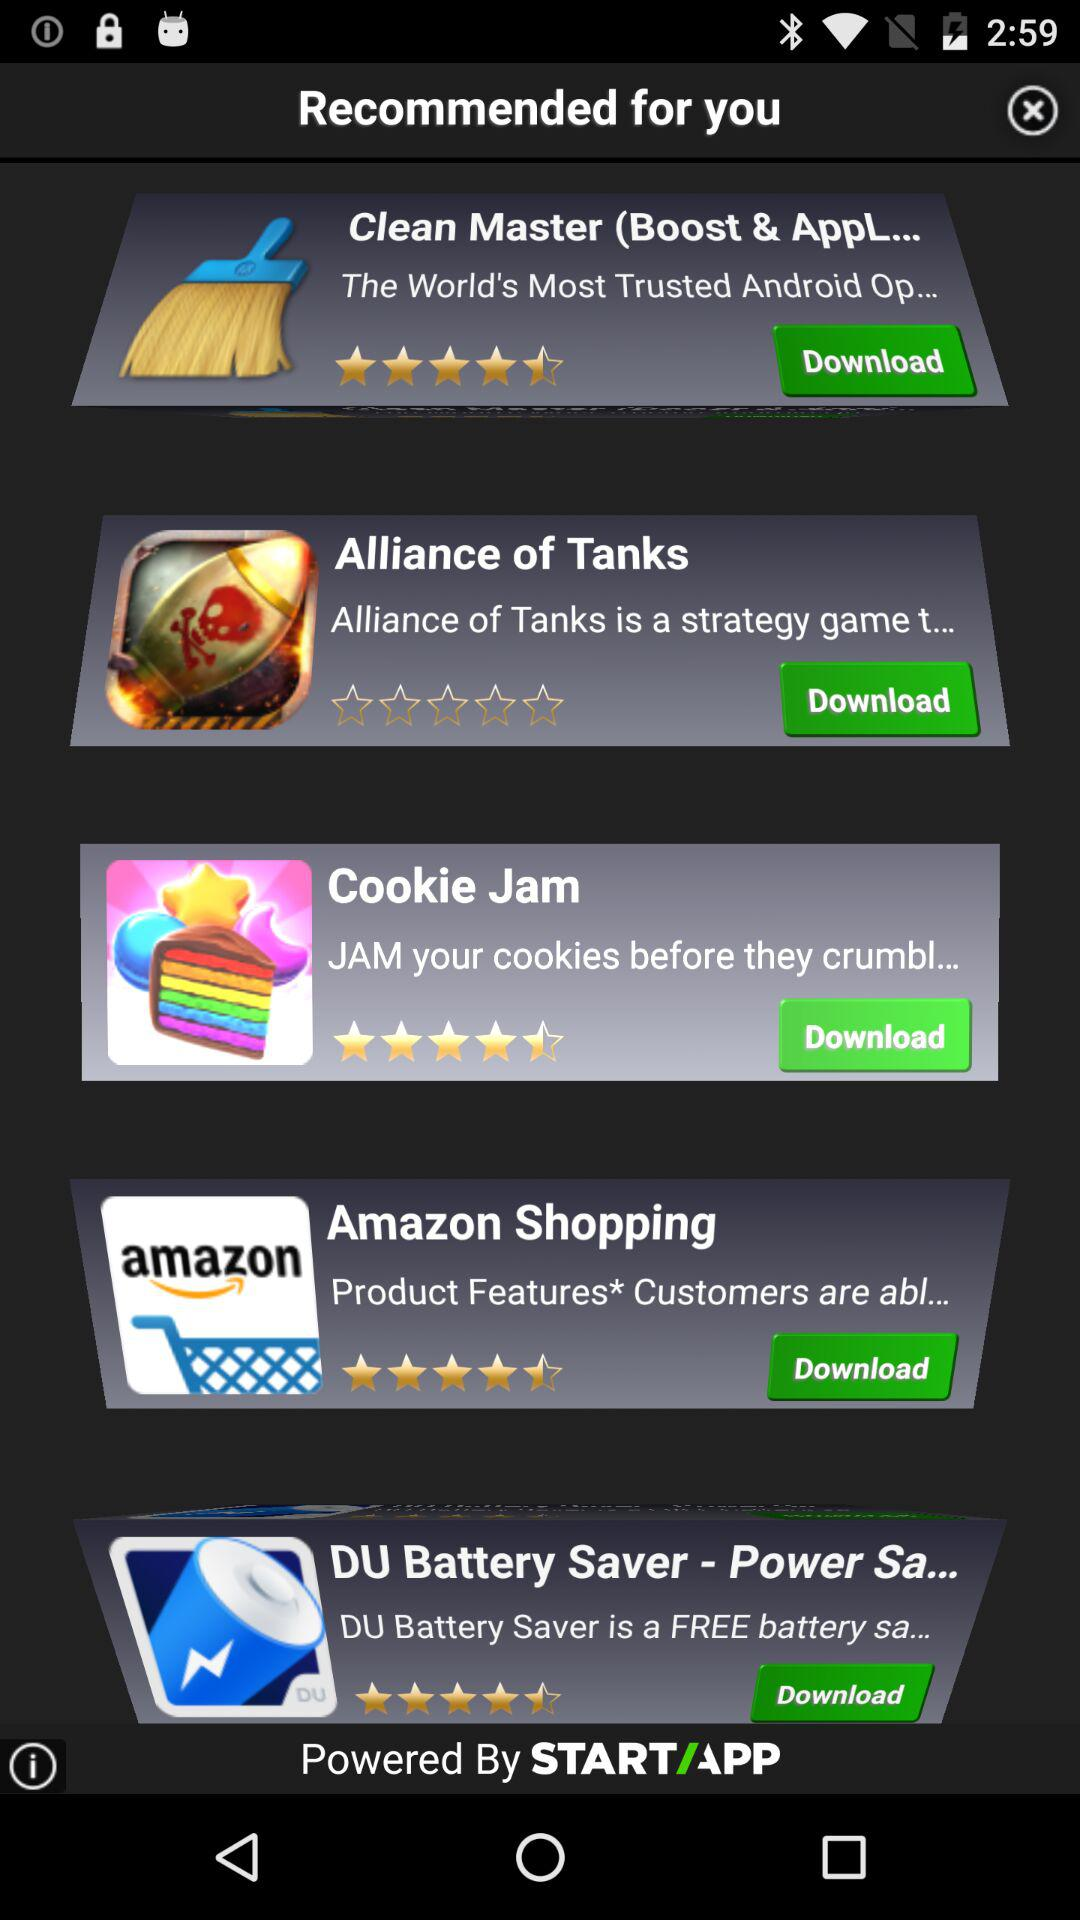What is the ratings for "Amazon Shopping"? The rating is 4.5 stars. 